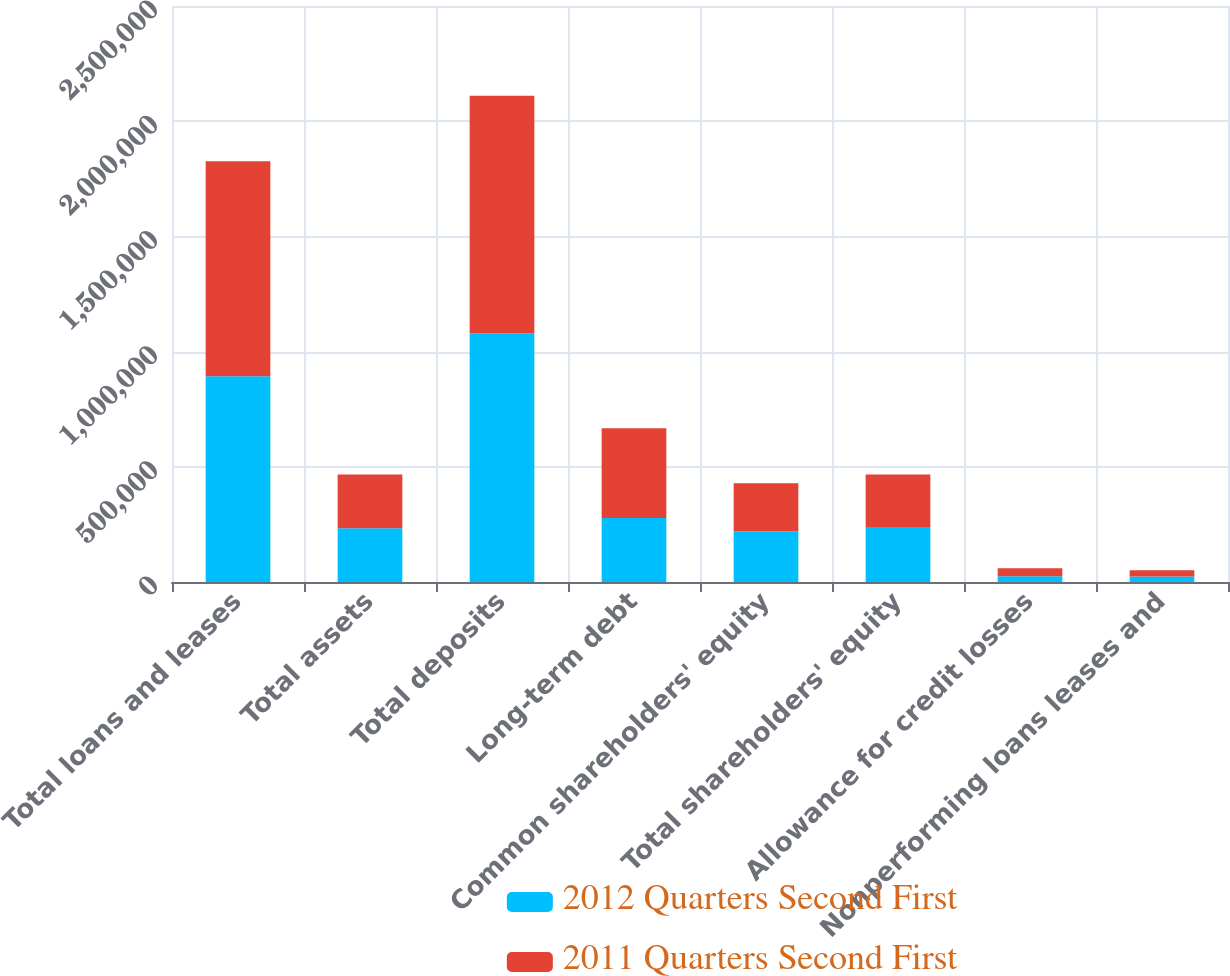Convert chart. <chart><loc_0><loc_0><loc_500><loc_500><stacked_bar_chart><ecel><fcel>Total loans and leases<fcel>Total assets<fcel>Total deposits<fcel>Long-term debt<fcel>Common shareholders' equity<fcel>Total shareholders' equity<fcel>Allowance for credit losses<fcel>Nonperforming loans leases and<nl><fcel>2012 Quarters Second First<fcel>893166<fcel>233374<fcel>1.07808e+06<fcel>277894<fcel>219744<fcel>238512<fcel>24692<fcel>23555<nl><fcel>2011 Quarters Second First<fcel>932898<fcel>233374<fcel>1.03253e+06<fcel>389557<fcel>209324<fcel>228235<fcel>34497<fcel>27708<nl></chart> 